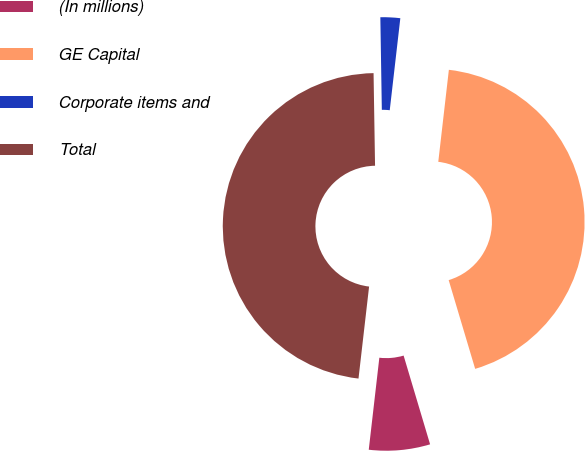Convert chart to OTSL. <chart><loc_0><loc_0><loc_500><loc_500><pie_chart><fcel>(In millions)<fcel>GE Capital<fcel>Corporate items and<fcel>Total<nl><fcel>6.44%<fcel>43.56%<fcel>2.08%<fcel>47.92%<nl></chart> 